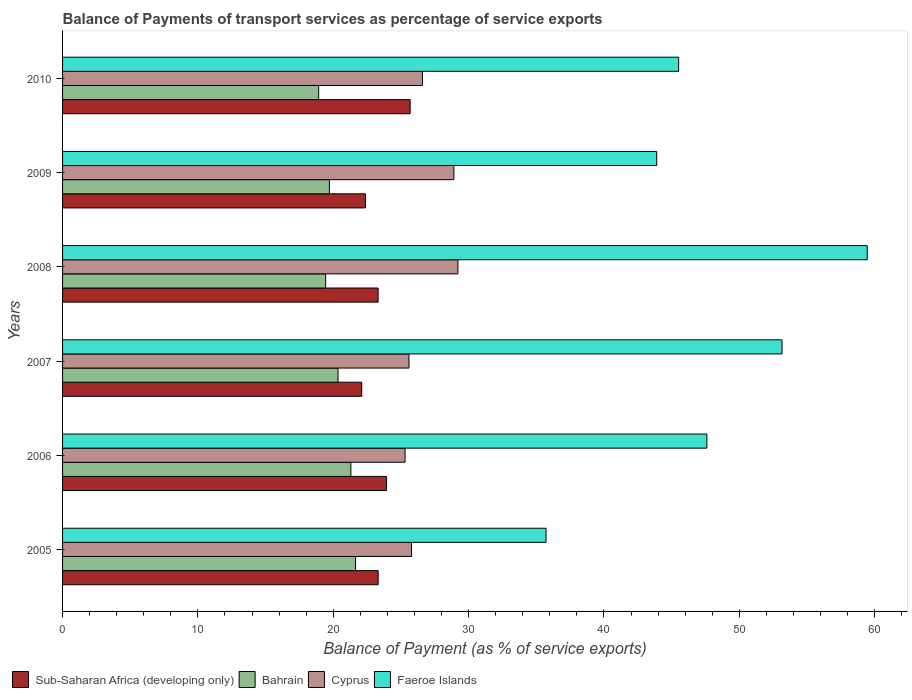How many different coloured bars are there?
Offer a very short reply. 4. Are the number of bars per tick equal to the number of legend labels?
Offer a very short reply. Yes. Are the number of bars on each tick of the Y-axis equal?
Offer a very short reply. Yes. How many bars are there on the 1st tick from the bottom?
Make the answer very short. 4. What is the label of the 1st group of bars from the top?
Keep it short and to the point. 2010. What is the balance of payments of transport services in Cyprus in 2005?
Offer a terse response. 25.78. Across all years, what is the maximum balance of payments of transport services in Bahrain?
Keep it short and to the point. 21.65. Across all years, what is the minimum balance of payments of transport services in Sub-Saharan Africa (developing only)?
Offer a very short reply. 22.1. In which year was the balance of payments of transport services in Sub-Saharan Africa (developing only) maximum?
Ensure brevity in your answer.  2010. What is the total balance of payments of transport services in Bahrain in the graph?
Your response must be concise. 121.38. What is the difference between the balance of payments of transport services in Sub-Saharan Africa (developing only) in 2007 and that in 2009?
Make the answer very short. -0.27. What is the difference between the balance of payments of transport services in Cyprus in 2009 and the balance of payments of transport services in Faeroe Islands in 2007?
Ensure brevity in your answer.  -24.25. What is the average balance of payments of transport services in Sub-Saharan Africa (developing only) per year?
Provide a short and direct response. 23.46. In the year 2009, what is the difference between the balance of payments of transport services in Cyprus and balance of payments of transport services in Bahrain?
Your answer should be very brief. 9.2. In how many years, is the balance of payments of transport services in Faeroe Islands greater than 14 %?
Offer a terse response. 6. What is the ratio of the balance of payments of transport services in Faeroe Islands in 2005 to that in 2010?
Offer a terse response. 0.78. Is the balance of payments of transport services in Bahrain in 2005 less than that in 2008?
Ensure brevity in your answer.  No. What is the difference between the highest and the second highest balance of payments of transport services in Bahrain?
Your answer should be compact. 0.35. What is the difference between the highest and the lowest balance of payments of transport services in Bahrain?
Provide a succinct answer. 2.72. In how many years, is the balance of payments of transport services in Faeroe Islands greater than the average balance of payments of transport services in Faeroe Islands taken over all years?
Offer a terse response. 3. What does the 1st bar from the top in 2008 represents?
Your answer should be very brief. Faeroe Islands. What does the 4th bar from the bottom in 2006 represents?
Make the answer very short. Faeroe Islands. How many bars are there?
Make the answer very short. 24. Are all the bars in the graph horizontal?
Make the answer very short. Yes. Are the values on the major ticks of X-axis written in scientific E-notation?
Provide a short and direct response. No. Where does the legend appear in the graph?
Make the answer very short. Bottom left. How many legend labels are there?
Provide a short and direct response. 4. How are the legend labels stacked?
Give a very brief answer. Horizontal. What is the title of the graph?
Your answer should be compact. Balance of Payments of transport services as percentage of service exports. Does "Ecuador" appear as one of the legend labels in the graph?
Offer a terse response. No. What is the label or title of the X-axis?
Offer a terse response. Balance of Payment (as % of service exports). What is the label or title of the Y-axis?
Provide a succinct answer. Years. What is the Balance of Payment (as % of service exports) of Sub-Saharan Africa (developing only) in 2005?
Your answer should be compact. 23.32. What is the Balance of Payment (as % of service exports) in Bahrain in 2005?
Make the answer very short. 21.65. What is the Balance of Payment (as % of service exports) of Cyprus in 2005?
Provide a short and direct response. 25.78. What is the Balance of Payment (as % of service exports) of Faeroe Islands in 2005?
Your answer should be compact. 35.72. What is the Balance of Payment (as % of service exports) in Sub-Saharan Africa (developing only) in 2006?
Your answer should be very brief. 23.94. What is the Balance of Payment (as % of service exports) in Bahrain in 2006?
Your answer should be very brief. 21.3. What is the Balance of Payment (as % of service exports) in Cyprus in 2006?
Your answer should be very brief. 25.31. What is the Balance of Payment (as % of service exports) in Faeroe Islands in 2006?
Ensure brevity in your answer.  47.61. What is the Balance of Payment (as % of service exports) of Sub-Saharan Africa (developing only) in 2007?
Provide a succinct answer. 22.1. What is the Balance of Payment (as % of service exports) in Bahrain in 2007?
Give a very brief answer. 20.35. What is the Balance of Payment (as % of service exports) in Cyprus in 2007?
Keep it short and to the point. 25.6. What is the Balance of Payment (as % of service exports) in Faeroe Islands in 2007?
Offer a terse response. 53.16. What is the Balance of Payment (as % of service exports) in Sub-Saharan Africa (developing only) in 2008?
Your response must be concise. 23.32. What is the Balance of Payment (as % of service exports) of Bahrain in 2008?
Offer a very short reply. 19.44. What is the Balance of Payment (as % of service exports) of Cyprus in 2008?
Your answer should be very brief. 29.21. What is the Balance of Payment (as % of service exports) of Faeroe Islands in 2008?
Ensure brevity in your answer.  59.46. What is the Balance of Payment (as % of service exports) in Sub-Saharan Africa (developing only) in 2009?
Ensure brevity in your answer.  22.38. What is the Balance of Payment (as % of service exports) in Bahrain in 2009?
Provide a succinct answer. 19.72. What is the Balance of Payment (as % of service exports) in Cyprus in 2009?
Offer a very short reply. 28.91. What is the Balance of Payment (as % of service exports) of Faeroe Islands in 2009?
Provide a succinct answer. 43.9. What is the Balance of Payment (as % of service exports) in Sub-Saharan Africa (developing only) in 2010?
Ensure brevity in your answer.  25.68. What is the Balance of Payment (as % of service exports) of Bahrain in 2010?
Your answer should be very brief. 18.92. What is the Balance of Payment (as % of service exports) of Cyprus in 2010?
Make the answer very short. 26.59. What is the Balance of Payment (as % of service exports) of Faeroe Islands in 2010?
Ensure brevity in your answer.  45.52. Across all years, what is the maximum Balance of Payment (as % of service exports) of Sub-Saharan Africa (developing only)?
Give a very brief answer. 25.68. Across all years, what is the maximum Balance of Payment (as % of service exports) of Bahrain?
Your response must be concise. 21.65. Across all years, what is the maximum Balance of Payment (as % of service exports) of Cyprus?
Your answer should be compact. 29.21. Across all years, what is the maximum Balance of Payment (as % of service exports) of Faeroe Islands?
Give a very brief answer. 59.46. Across all years, what is the minimum Balance of Payment (as % of service exports) of Sub-Saharan Africa (developing only)?
Keep it short and to the point. 22.1. Across all years, what is the minimum Balance of Payment (as % of service exports) in Bahrain?
Make the answer very short. 18.92. Across all years, what is the minimum Balance of Payment (as % of service exports) of Cyprus?
Your answer should be very brief. 25.31. Across all years, what is the minimum Balance of Payment (as % of service exports) in Faeroe Islands?
Give a very brief answer. 35.72. What is the total Balance of Payment (as % of service exports) of Sub-Saharan Africa (developing only) in the graph?
Ensure brevity in your answer.  140.73. What is the total Balance of Payment (as % of service exports) of Bahrain in the graph?
Offer a terse response. 121.38. What is the total Balance of Payment (as % of service exports) of Cyprus in the graph?
Make the answer very short. 161.4. What is the total Balance of Payment (as % of service exports) of Faeroe Islands in the graph?
Give a very brief answer. 285.37. What is the difference between the Balance of Payment (as % of service exports) of Sub-Saharan Africa (developing only) in 2005 and that in 2006?
Give a very brief answer. -0.62. What is the difference between the Balance of Payment (as % of service exports) in Bahrain in 2005 and that in 2006?
Your answer should be very brief. 0.35. What is the difference between the Balance of Payment (as % of service exports) of Cyprus in 2005 and that in 2006?
Offer a terse response. 0.48. What is the difference between the Balance of Payment (as % of service exports) in Faeroe Islands in 2005 and that in 2006?
Offer a very short reply. -11.88. What is the difference between the Balance of Payment (as % of service exports) in Sub-Saharan Africa (developing only) in 2005 and that in 2007?
Offer a terse response. 1.22. What is the difference between the Balance of Payment (as % of service exports) of Bahrain in 2005 and that in 2007?
Offer a terse response. 1.29. What is the difference between the Balance of Payment (as % of service exports) in Cyprus in 2005 and that in 2007?
Provide a succinct answer. 0.19. What is the difference between the Balance of Payment (as % of service exports) in Faeroe Islands in 2005 and that in 2007?
Offer a terse response. -17.44. What is the difference between the Balance of Payment (as % of service exports) in Sub-Saharan Africa (developing only) in 2005 and that in 2008?
Your answer should be compact. 0. What is the difference between the Balance of Payment (as % of service exports) in Bahrain in 2005 and that in 2008?
Make the answer very short. 2.21. What is the difference between the Balance of Payment (as % of service exports) of Cyprus in 2005 and that in 2008?
Keep it short and to the point. -3.43. What is the difference between the Balance of Payment (as % of service exports) of Faeroe Islands in 2005 and that in 2008?
Make the answer very short. -23.73. What is the difference between the Balance of Payment (as % of service exports) in Sub-Saharan Africa (developing only) in 2005 and that in 2009?
Keep it short and to the point. 0.94. What is the difference between the Balance of Payment (as % of service exports) of Bahrain in 2005 and that in 2009?
Your response must be concise. 1.93. What is the difference between the Balance of Payment (as % of service exports) in Cyprus in 2005 and that in 2009?
Provide a succinct answer. -3.13. What is the difference between the Balance of Payment (as % of service exports) of Faeroe Islands in 2005 and that in 2009?
Offer a very short reply. -8.18. What is the difference between the Balance of Payment (as % of service exports) in Sub-Saharan Africa (developing only) in 2005 and that in 2010?
Ensure brevity in your answer.  -2.36. What is the difference between the Balance of Payment (as % of service exports) of Bahrain in 2005 and that in 2010?
Keep it short and to the point. 2.73. What is the difference between the Balance of Payment (as % of service exports) of Cyprus in 2005 and that in 2010?
Offer a very short reply. -0.81. What is the difference between the Balance of Payment (as % of service exports) in Faeroe Islands in 2005 and that in 2010?
Make the answer very short. -9.8. What is the difference between the Balance of Payment (as % of service exports) in Sub-Saharan Africa (developing only) in 2006 and that in 2007?
Provide a succinct answer. 1.83. What is the difference between the Balance of Payment (as % of service exports) of Bahrain in 2006 and that in 2007?
Keep it short and to the point. 0.95. What is the difference between the Balance of Payment (as % of service exports) in Cyprus in 2006 and that in 2007?
Give a very brief answer. -0.29. What is the difference between the Balance of Payment (as % of service exports) of Faeroe Islands in 2006 and that in 2007?
Your answer should be compact. -5.55. What is the difference between the Balance of Payment (as % of service exports) in Sub-Saharan Africa (developing only) in 2006 and that in 2008?
Ensure brevity in your answer.  0.62. What is the difference between the Balance of Payment (as % of service exports) in Bahrain in 2006 and that in 2008?
Your answer should be compact. 1.86. What is the difference between the Balance of Payment (as % of service exports) in Cyprus in 2006 and that in 2008?
Give a very brief answer. -3.91. What is the difference between the Balance of Payment (as % of service exports) in Faeroe Islands in 2006 and that in 2008?
Provide a succinct answer. -11.85. What is the difference between the Balance of Payment (as % of service exports) of Sub-Saharan Africa (developing only) in 2006 and that in 2009?
Provide a succinct answer. 1.56. What is the difference between the Balance of Payment (as % of service exports) in Bahrain in 2006 and that in 2009?
Provide a short and direct response. 1.59. What is the difference between the Balance of Payment (as % of service exports) of Cyprus in 2006 and that in 2009?
Offer a terse response. -3.61. What is the difference between the Balance of Payment (as % of service exports) in Faeroe Islands in 2006 and that in 2009?
Offer a very short reply. 3.71. What is the difference between the Balance of Payment (as % of service exports) in Sub-Saharan Africa (developing only) in 2006 and that in 2010?
Make the answer very short. -1.75. What is the difference between the Balance of Payment (as % of service exports) in Bahrain in 2006 and that in 2010?
Offer a terse response. 2.38. What is the difference between the Balance of Payment (as % of service exports) of Cyprus in 2006 and that in 2010?
Offer a terse response. -1.28. What is the difference between the Balance of Payment (as % of service exports) in Faeroe Islands in 2006 and that in 2010?
Provide a short and direct response. 2.09. What is the difference between the Balance of Payment (as % of service exports) in Sub-Saharan Africa (developing only) in 2007 and that in 2008?
Provide a succinct answer. -1.21. What is the difference between the Balance of Payment (as % of service exports) in Bahrain in 2007 and that in 2008?
Keep it short and to the point. 0.92. What is the difference between the Balance of Payment (as % of service exports) in Cyprus in 2007 and that in 2008?
Ensure brevity in your answer.  -3.62. What is the difference between the Balance of Payment (as % of service exports) of Faeroe Islands in 2007 and that in 2008?
Your answer should be compact. -6.3. What is the difference between the Balance of Payment (as % of service exports) in Sub-Saharan Africa (developing only) in 2007 and that in 2009?
Make the answer very short. -0.27. What is the difference between the Balance of Payment (as % of service exports) in Bahrain in 2007 and that in 2009?
Offer a very short reply. 0.64. What is the difference between the Balance of Payment (as % of service exports) of Cyprus in 2007 and that in 2009?
Your response must be concise. -3.32. What is the difference between the Balance of Payment (as % of service exports) of Faeroe Islands in 2007 and that in 2009?
Your answer should be compact. 9.26. What is the difference between the Balance of Payment (as % of service exports) of Sub-Saharan Africa (developing only) in 2007 and that in 2010?
Your answer should be very brief. -3.58. What is the difference between the Balance of Payment (as % of service exports) in Bahrain in 2007 and that in 2010?
Make the answer very short. 1.43. What is the difference between the Balance of Payment (as % of service exports) of Cyprus in 2007 and that in 2010?
Make the answer very short. -0.99. What is the difference between the Balance of Payment (as % of service exports) in Faeroe Islands in 2007 and that in 2010?
Provide a succinct answer. 7.64. What is the difference between the Balance of Payment (as % of service exports) in Sub-Saharan Africa (developing only) in 2008 and that in 2009?
Your response must be concise. 0.94. What is the difference between the Balance of Payment (as % of service exports) of Bahrain in 2008 and that in 2009?
Provide a succinct answer. -0.28. What is the difference between the Balance of Payment (as % of service exports) in Cyprus in 2008 and that in 2009?
Offer a very short reply. 0.3. What is the difference between the Balance of Payment (as % of service exports) of Faeroe Islands in 2008 and that in 2009?
Your answer should be very brief. 15.56. What is the difference between the Balance of Payment (as % of service exports) in Sub-Saharan Africa (developing only) in 2008 and that in 2010?
Your response must be concise. -2.37. What is the difference between the Balance of Payment (as % of service exports) in Bahrain in 2008 and that in 2010?
Make the answer very short. 0.52. What is the difference between the Balance of Payment (as % of service exports) in Cyprus in 2008 and that in 2010?
Offer a terse response. 2.62. What is the difference between the Balance of Payment (as % of service exports) in Faeroe Islands in 2008 and that in 2010?
Offer a very short reply. 13.94. What is the difference between the Balance of Payment (as % of service exports) of Sub-Saharan Africa (developing only) in 2009 and that in 2010?
Offer a very short reply. -3.3. What is the difference between the Balance of Payment (as % of service exports) of Bahrain in 2009 and that in 2010?
Your answer should be compact. 0.79. What is the difference between the Balance of Payment (as % of service exports) in Cyprus in 2009 and that in 2010?
Offer a terse response. 2.32. What is the difference between the Balance of Payment (as % of service exports) in Faeroe Islands in 2009 and that in 2010?
Give a very brief answer. -1.62. What is the difference between the Balance of Payment (as % of service exports) of Sub-Saharan Africa (developing only) in 2005 and the Balance of Payment (as % of service exports) of Bahrain in 2006?
Make the answer very short. 2.02. What is the difference between the Balance of Payment (as % of service exports) of Sub-Saharan Africa (developing only) in 2005 and the Balance of Payment (as % of service exports) of Cyprus in 2006?
Your response must be concise. -1.99. What is the difference between the Balance of Payment (as % of service exports) in Sub-Saharan Africa (developing only) in 2005 and the Balance of Payment (as % of service exports) in Faeroe Islands in 2006?
Provide a short and direct response. -24.29. What is the difference between the Balance of Payment (as % of service exports) in Bahrain in 2005 and the Balance of Payment (as % of service exports) in Cyprus in 2006?
Ensure brevity in your answer.  -3.66. What is the difference between the Balance of Payment (as % of service exports) in Bahrain in 2005 and the Balance of Payment (as % of service exports) in Faeroe Islands in 2006?
Your response must be concise. -25.96. What is the difference between the Balance of Payment (as % of service exports) of Cyprus in 2005 and the Balance of Payment (as % of service exports) of Faeroe Islands in 2006?
Your answer should be compact. -21.82. What is the difference between the Balance of Payment (as % of service exports) of Sub-Saharan Africa (developing only) in 2005 and the Balance of Payment (as % of service exports) of Bahrain in 2007?
Keep it short and to the point. 2.96. What is the difference between the Balance of Payment (as % of service exports) in Sub-Saharan Africa (developing only) in 2005 and the Balance of Payment (as % of service exports) in Cyprus in 2007?
Make the answer very short. -2.28. What is the difference between the Balance of Payment (as % of service exports) of Sub-Saharan Africa (developing only) in 2005 and the Balance of Payment (as % of service exports) of Faeroe Islands in 2007?
Your response must be concise. -29.84. What is the difference between the Balance of Payment (as % of service exports) in Bahrain in 2005 and the Balance of Payment (as % of service exports) in Cyprus in 2007?
Offer a terse response. -3.95. What is the difference between the Balance of Payment (as % of service exports) in Bahrain in 2005 and the Balance of Payment (as % of service exports) in Faeroe Islands in 2007?
Your answer should be very brief. -31.51. What is the difference between the Balance of Payment (as % of service exports) in Cyprus in 2005 and the Balance of Payment (as % of service exports) in Faeroe Islands in 2007?
Offer a terse response. -27.38. What is the difference between the Balance of Payment (as % of service exports) in Sub-Saharan Africa (developing only) in 2005 and the Balance of Payment (as % of service exports) in Bahrain in 2008?
Provide a succinct answer. 3.88. What is the difference between the Balance of Payment (as % of service exports) of Sub-Saharan Africa (developing only) in 2005 and the Balance of Payment (as % of service exports) of Cyprus in 2008?
Provide a succinct answer. -5.89. What is the difference between the Balance of Payment (as % of service exports) in Sub-Saharan Africa (developing only) in 2005 and the Balance of Payment (as % of service exports) in Faeroe Islands in 2008?
Your answer should be very brief. -36.14. What is the difference between the Balance of Payment (as % of service exports) in Bahrain in 2005 and the Balance of Payment (as % of service exports) in Cyprus in 2008?
Your answer should be very brief. -7.56. What is the difference between the Balance of Payment (as % of service exports) of Bahrain in 2005 and the Balance of Payment (as % of service exports) of Faeroe Islands in 2008?
Give a very brief answer. -37.81. What is the difference between the Balance of Payment (as % of service exports) of Cyprus in 2005 and the Balance of Payment (as % of service exports) of Faeroe Islands in 2008?
Your answer should be very brief. -33.67. What is the difference between the Balance of Payment (as % of service exports) in Sub-Saharan Africa (developing only) in 2005 and the Balance of Payment (as % of service exports) in Bahrain in 2009?
Give a very brief answer. 3.6. What is the difference between the Balance of Payment (as % of service exports) in Sub-Saharan Africa (developing only) in 2005 and the Balance of Payment (as % of service exports) in Cyprus in 2009?
Offer a very short reply. -5.6. What is the difference between the Balance of Payment (as % of service exports) of Sub-Saharan Africa (developing only) in 2005 and the Balance of Payment (as % of service exports) of Faeroe Islands in 2009?
Ensure brevity in your answer.  -20.58. What is the difference between the Balance of Payment (as % of service exports) of Bahrain in 2005 and the Balance of Payment (as % of service exports) of Cyprus in 2009?
Your answer should be very brief. -7.27. What is the difference between the Balance of Payment (as % of service exports) in Bahrain in 2005 and the Balance of Payment (as % of service exports) in Faeroe Islands in 2009?
Keep it short and to the point. -22.25. What is the difference between the Balance of Payment (as % of service exports) in Cyprus in 2005 and the Balance of Payment (as % of service exports) in Faeroe Islands in 2009?
Offer a terse response. -18.12. What is the difference between the Balance of Payment (as % of service exports) of Sub-Saharan Africa (developing only) in 2005 and the Balance of Payment (as % of service exports) of Bahrain in 2010?
Keep it short and to the point. 4.39. What is the difference between the Balance of Payment (as % of service exports) of Sub-Saharan Africa (developing only) in 2005 and the Balance of Payment (as % of service exports) of Cyprus in 2010?
Make the answer very short. -3.27. What is the difference between the Balance of Payment (as % of service exports) in Sub-Saharan Africa (developing only) in 2005 and the Balance of Payment (as % of service exports) in Faeroe Islands in 2010?
Your answer should be compact. -22.2. What is the difference between the Balance of Payment (as % of service exports) of Bahrain in 2005 and the Balance of Payment (as % of service exports) of Cyprus in 2010?
Your response must be concise. -4.94. What is the difference between the Balance of Payment (as % of service exports) of Bahrain in 2005 and the Balance of Payment (as % of service exports) of Faeroe Islands in 2010?
Provide a short and direct response. -23.87. What is the difference between the Balance of Payment (as % of service exports) of Cyprus in 2005 and the Balance of Payment (as % of service exports) of Faeroe Islands in 2010?
Offer a very short reply. -19.74. What is the difference between the Balance of Payment (as % of service exports) in Sub-Saharan Africa (developing only) in 2006 and the Balance of Payment (as % of service exports) in Bahrain in 2007?
Your response must be concise. 3.58. What is the difference between the Balance of Payment (as % of service exports) in Sub-Saharan Africa (developing only) in 2006 and the Balance of Payment (as % of service exports) in Cyprus in 2007?
Make the answer very short. -1.66. What is the difference between the Balance of Payment (as % of service exports) of Sub-Saharan Africa (developing only) in 2006 and the Balance of Payment (as % of service exports) of Faeroe Islands in 2007?
Your answer should be very brief. -29.22. What is the difference between the Balance of Payment (as % of service exports) of Bahrain in 2006 and the Balance of Payment (as % of service exports) of Cyprus in 2007?
Provide a short and direct response. -4.29. What is the difference between the Balance of Payment (as % of service exports) in Bahrain in 2006 and the Balance of Payment (as % of service exports) in Faeroe Islands in 2007?
Keep it short and to the point. -31.86. What is the difference between the Balance of Payment (as % of service exports) of Cyprus in 2006 and the Balance of Payment (as % of service exports) of Faeroe Islands in 2007?
Ensure brevity in your answer.  -27.85. What is the difference between the Balance of Payment (as % of service exports) of Sub-Saharan Africa (developing only) in 2006 and the Balance of Payment (as % of service exports) of Bahrain in 2008?
Make the answer very short. 4.5. What is the difference between the Balance of Payment (as % of service exports) of Sub-Saharan Africa (developing only) in 2006 and the Balance of Payment (as % of service exports) of Cyprus in 2008?
Your answer should be compact. -5.28. What is the difference between the Balance of Payment (as % of service exports) of Sub-Saharan Africa (developing only) in 2006 and the Balance of Payment (as % of service exports) of Faeroe Islands in 2008?
Provide a succinct answer. -35.52. What is the difference between the Balance of Payment (as % of service exports) of Bahrain in 2006 and the Balance of Payment (as % of service exports) of Cyprus in 2008?
Give a very brief answer. -7.91. What is the difference between the Balance of Payment (as % of service exports) in Bahrain in 2006 and the Balance of Payment (as % of service exports) in Faeroe Islands in 2008?
Provide a short and direct response. -38.16. What is the difference between the Balance of Payment (as % of service exports) of Cyprus in 2006 and the Balance of Payment (as % of service exports) of Faeroe Islands in 2008?
Provide a succinct answer. -34.15. What is the difference between the Balance of Payment (as % of service exports) in Sub-Saharan Africa (developing only) in 2006 and the Balance of Payment (as % of service exports) in Bahrain in 2009?
Ensure brevity in your answer.  4.22. What is the difference between the Balance of Payment (as % of service exports) in Sub-Saharan Africa (developing only) in 2006 and the Balance of Payment (as % of service exports) in Cyprus in 2009?
Your answer should be very brief. -4.98. What is the difference between the Balance of Payment (as % of service exports) in Sub-Saharan Africa (developing only) in 2006 and the Balance of Payment (as % of service exports) in Faeroe Islands in 2009?
Ensure brevity in your answer.  -19.96. What is the difference between the Balance of Payment (as % of service exports) in Bahrain in 2006 and the Balance of Payment (as % of service exports) in Cyprus in 2009?
Your response must be concise. -7.61. What is the difference between the Balance of Payment (as % of service exports) in Bahrain in 2006 and the Balance of Payment (as % of service exports) in Faeroe Islands in 2009?
Offer a very short reply. -22.6. What is the difference between the Balance of Payment (as % of service exports) in Cyprus in 2006 and the Balance of Payment (as % of service exports) in Faeroe Islands in 2009?
Your answer should be compact. -18.59. What is the difference between the Balance of Payment (as % of service exports) in Sub-Saharan Africa (developing only) in 2006 and the Balance of Payment (as % of service exports) in Bahrain in 2010?
Provide a short and direct response. 5.01. What is the difference between the Balance of Payment (as % of service exports) in Sub-Saharan Africa (developing only) in 2006 and the Balance of Payment (as % of service exports) in Cyprus in 2010?
Your answer should be very brief. -2.65. What is the difference between the Balance of Payment (as % of service exports) of Sub-Saharan Africa (developing only) in 2006 and the Balance of Payment (as % of service exports) of Faeroe Islands in 2010?
Make the answer very short. -21.58. What is the difference between the Balance of Payment (as % of service exports) of Bahrain in 2006 and the Balance of Payment (as % of service exports) of Cyprus in 2010?
Your answer should be very brief. -5.29. What is the difference between the Balance of Payment (as % of service exports) in Bahrain in 2006 and the Balance of Payment (as % of service exports) in Faeroe Islands in 2010?
Offer a terse response. -24.22. What is the difference between the Balance of Payment (as % of service exports) in Cyprus in 2006 and the Balance of Payment (as % of service exports) in Faeroe Islands in 2010?
Offer a very short reply. -20.21. What is the difference between the Balance of Payment (as % of service exports) of Sub-Saharan Africa (developing only) in 2007 and the Balance of Payment (as % of service exports) of Bahrain in 2008?
Ensure brevity in your answer.  2.66. What is the difference between the Balance of Payment (as % of service exports) in Sub-Saharan Africa (developing only) in 2007 and the Balance of Payment (as % of service exports) in Cyprus in 2008?
Provide a succinct answer. -7.11. What is the difference between the Balance of Payment (as % of service exports) in Sub-Saharan Africa (developing only) in 2007 and the Balance of Payment (as % of service exports) in Faeroe Islands in 2008?
Offer a very short reply. -37.35. What is the difference between the Balance of Payment (as % of service exports) in Bahrain in 2007 and the Balance of Payment (as % of service exports) in Cyprus in 2008?
Provide a short and direct response. -8.86. What is the difference between the Balance of Payment (as % of service exports) of Bahrain in 2007 and the Balance of Payment (as % of service exports) of Faeroe Islands in 2008?
Provide a short and direct response. -39.1. What is the difference between the Balance of Payment (as % of service exports) in Cyprus in 2007 and the Balance of Payment (as % of service exports) in Faeroe Islands in 2008?
Provide a short and direct response. -33.86. What is the difference between the Balance of Payment (as % of service exports) in Sub-Saharan Africa (developing only) in 2007 and the Balance of Payment (as % of service exports) in Bahrain in 2009?
Offer a terse response. 2.39. What is the difference between the Balance of Payment (as % of service exports) of Sub-Saharan Africa (developing only) in 2007 and the Balance of Payment (as % of service exports) of Cyprus in 2009?
Ensure brevity in your answer.  -6.81. What is the difference between the Balance of Payment (as % of service exports) of Sub-Saharan Africa (developing only) in 2007 and the Balance of Payment (as % of service exports) of Faeroe Islands in 2009?
Make the answer very short. -21.8. What is the difference between the Balance of Payment (as % of service exports) of Bahrain in 2007 and the Balance of Payment (as % of service exports) of Cyprus in 2009?
Your response must be concise. -8.56. What is the difference between the Balance of Payment (as % of service exports) in Bahrain in 2007 and the Balance of Payment (as % of service exports) in Faeroe Islands in 2009?
Your answer should be compact. -23.55. What is the difference between the Balance of Payment (as % of service exports) of Cyprus in 2007 and the Balance of Payment (as % of service exports) of Faeroe Islands in 2009?
Your answer should be compact. -18.3. What is the difference between the Balance of Payment (as % of service exports) in Sub-Saharan Africa (developing only) in 2007 and the Balance of Payment (as % of service exports) in Bahrain in 2010?
Provide a short and direct response. 3.18. What is the difference between the Balance of Payment (as % of service exports) in Sub-Saharan Africa (developing only) in 2007 and the Balance of Payment (as % of service exports) in Cyprus in 2010?
Offer a terse response. -4.49. What is the difference between the Balance of Payment (as % of service exports) of Sub-Saharan Africa (developing only) in 2007 and the Balance of Payment (as % of service exports) of Faeroe Islands in 2010?
Your answer should be very brief. -23.42. What is the difference between the Balance of Payment (as % of service exports) of Bahrain in 2007 and the Balance of Payment (as % of service exports) of Cyprus in 2010?
Make the answer very short. -6.24. What is the difference between the Balance of Payment (as % of service exports) in Bahrain in 2007 and the Balance of Payment (as % of service exports) in Faeroe Islands in 2010?
Keep it short and to the point. -25.16. What is the difference between the Balance of Payment (as % of service exports) of Cyprus in 2007 and the Balance of Payment (as % of service exports) of Faeroe Islands in 2010?
Provide a succinct answer. -19.92. What is the difference between the Balance of Payment (as % of service exports) in Sub-Saharan Africa (developing only) in 2008 and the Balance of Payment (as % of service exports) in Bahrain in 2009?
Your response must be concise. 3.6. What is the difference between the Balance of Payment (as % of service exports) of Sub-Saharan Africa (developing only) in 2008 and the Balance of Payment (as % of service exports) of Cyprus in 2009?
Ensure brevity in your answer.  -5.6. What is the difference between the Balance of Payment (as % of service exports) in Sub-Saharan Africa (developing only) in 2008 and the Balance of Payment (as % of service exports) in Faeroe Islands in 2009?
Offer a terse response. -20.58. What is the difference between the Balance of Payment (as % of service exports) of Bahrain in 2008 and the Balance of Payment (as % of service exports) of Cyprus in 2009?
Offer a very short reply. -9.47. What is the difference between the Balance of Payment (as % of service exports) in Bahrain in 2008 and the Balance of Payment (as % of service exports) in Faeroe Islands in 2009?
Offer a very short reply. -24.46. What is the difference between the Balance of Payment (as % of service exports) of Cyprus in 2008 and the Balance of Payment (as % of service exports) of Faeroe Islands in 2009?
Your response must be concise. -14.69. What is the difference between the Balance of Payment (as % of service exports) in Sub-Saharan Africa (developing only) in 2008 and the Balance of Payment (as % of service exports) in Bahrain in 2010?
Provide a short and direct response. 4.39. What is the difference between the Balance of Payment (as % of service exports) in Sub-Saharan Africa (developing only) in 2008 and the Balance of Payment (as % of service exports) in Cyprus in 2010?
Your response must be concise. -3.27. What is the difference between the Balance of Payment (as % of service exports) of Sub-Saharan Africa (developing only) in 2008 and the Balance of Payment (as % of service exports) of Faeroe Islands in 2010?
Keep it short and to the point. -22.2. What is the difference between the Balance of Payment (as % of service exports) in Bahrain in 2008 and the Balance of Payment (as % of service exports) in Cyprus in 2010?
Provide a succinct answer. -7.15. What is the difference between the Balance of Payment (as % of service exports) of Bahrain in 2008 and the Balance of Payment (as % of service exports) of Faeroe Islands in 2010?
Provide a succinct answer. -26.08. What is the difference between the Balance of Payment (as % of service exports) of Cyprus in 2008 and the Balance of Payment (as % of service exports) of Faeroe Islands in 2010?
Your response must be concise. -16.31. What is the difference between the Balance of Payment (as % of service exports) in Sub-Saharan Africa (developing only) in 2009 and the Balance of Payment (as % of service exports) in Bahrain in 2010?
Keep it short and to the point. 3.45. What is the difference between the Balance of Payment (as % of service exports) of Sub-Saharan Africa (developing only) in 2009 and the Balance of Payment (as % of service exports) of Cyprus in 2010?
Your response must be concise. -4.21. What is the difference between the Balance of Payment (as % of service exports) in Sub-Saharan Africa (developing only) in 2009 and the Balance of Payment (as % of service exports) in Faeroe Islands in 2010?
Ensure brevity in your answer.  -23.14. What is the difference between the Balance of Payment (as % of service exports) of Bahrain in 2009 and the Balance of Payment (as % of service exports) of Cyprus in 2010?
Provide a succinct answer. -6.87. What is the difference between the Balance of Payment (as % of service exports) in Bahrain in 2009 and the Balance of Payment (as % of service exports) in Faeroe Islands in 2010?
Offer a terse response. -25.8. What is the difference between the Balance of Payment (as % of service exports) in Cyprus in 2009 and the Balance of Payment (as % of service exports) in Faeroe Islands in 2010?
Offer a very short reply. -16.61. What is the average Balance of Payment (as % of service exports) in Sub-Saharan Africa (developing only) per year?
Provide a short and direct response. 23.46. What is the average Balance of Payment (as % of service exports) of Bahrain per year?
Offer a terse response. 20.23. What is the average Balance of Payment (as % of service exports) of Cyprus per year?
Provide a succinct answer. 26.9. What is the average Balance of Payment (as % of service exports) of Faeroe Islands per year?
Make the answer very short. 47.56. In the year 2005, what is the difference between the Balance of Payment (as % of service exports) of Sub-Saharan Africa (developing only) and Balance of Payment (as % of service exports) of Bahrain?
Provide a short and direct response. 1.67. In the year 2005, what is the difference between the Balance of Payment (as % of service exports) of Sub-Saharan Africa (developing only) and Balance of Payment (as % of service exports) of Cyprus?
Offer a terse response. -2.46. In the year 2005, what is the difference between the Balance of Payment (as % of service exports) in Sub-Saharan Africa (developing only) and Balance of Payment (as % of service exports) in Faeroe Islands?
Your answer should be compact. -12.41. In the year 2005, what is the difference between the Balance of Payment (as % of service exports) in Bahrain and Balance of Payment (as % of service exports) in Cyprus?
Your answer should be very brief. -4.13. In the year 2005, what is the difference between the Balance of Payment (as % of service exports) of Bahrain and Balance of Payment (as % of service exports) of Faeroe Islands?
Give a very brief answer. -14.08. In the year 2005, what is the difference between the Balance of Payment (as % of service exports) of Cyprus and Balance of Payment (as % of service exports) of Faeroe Islands?
Provide a short and direct response. -9.94. In the year 2006, what is the difference between the Balance of Payment (as % of service exports) in Sub-Saharan Africa (developing only) and Balance of Payment (as % of service exports) in Bahrain?
Offer a very short reply. 2.64. In the year 2006, what is the difference between the Balance of Payment (as % of service exports) in Sub-Saharan Africa (developing only) and Balance of Payment (as % of service exports) in Cyprus?
Offer a very short reply. -1.37. In the year 2006, what is the difference between the Balance of Payment (as % of service exports) in Sub-Saharan Africa (developing only) and Balance of Payment (as % of service exports) in Faeroe Islands?
Keep it short and to the point. -23.67. In the year 2006, what is the difference between the Balance of Payment (as % of service exports) of Bahrain and Balance of Payment (as % of service exports) of Cyprus?
Your answer should be very brief. -4.01. In the year 2006, what is the difference between the Balance of Payment (as % of service exports) of Bahrain and Balance of Payment (as % of service exports) of Faeroe Islands?
Make the answer very short. -26.31. In the year 2006, what is the difference between the Balance of Payment (as % of service exports) in Cyprus and Balance of Payment (as % of service exports) in Faeroe Islands?
Provide a succinct answer. -22.3. In the year 2007, what is the difference between the Balance of Payment (as % of service exports) of Sub-Saharan Africa (developing only) and Balance of Payment (as % of service exports) of Bahrain?
Offer a terse response. 1.75. In the year 2007, what is the difference between the Balance of Payment (as % of service exports) of Sub-Saharan Africa (developing only) and Balance of Payment (as % of service exports) of Cyprus?
Make the answer very short. -3.49. In the year 2007, what is the difference between the Balance of Payment (as % of service exports) in Sub-Saharan Africa (developing only) and Balance of Payment (as % of service exports) in Faeroe Islands?
Provide a succinct answer. -31.06. In the year 2007, what is the difference between the Balance of Payment (as % of service exports) in Bahrain and Balance of Payment (as % of service exports) in Cyprus?
Offer a terse response. -5.24. In the year 2007, what is the difference between the Balance of Payment (as % of service exports) of Bahrain and Balance of Payment (as % of service exports) of Faeroe Islands?
Offer a terse response. -32.81. In the year 2007, what is the difference between the Balance of Payment (as % of service exports) of Cyprus and Balance of Payment (as % of service exports) of Faeroe Islands?
Keep it short and to the point. -27.56. In the year 2008, what is the difference between the Balance of Payment (as % of service exports) of Sub-Saharan Africa (developing only) and Balance of Payment (as % of service exports) of Bahrain?
Keep it short and to the point. 3.88. In the year 2008, what is the difference between the Balance of Payment (as % of service exports) in Sub-Saharan Africa (developing only) and Balance of Payment (as % of service exports) in Cyprus?
Provide a succinct answer. -5.9. In the year 2008, what is the difference between the Balance of Payment (as % of service exports) of Sub-Saharan Africa (developing only) and Balance of Payment (as % of service exports) of Faeroe Islands?
Offer a very short reply. -36.14. In the year 2008, what is the difference between the Balance of Payment (as % of service exports) in Bahrain and Balance of Payment (as % of service exports) in Cyprus?
Make the answer very short. -9.77. In the year 2008, what is the difference between the Balance of Payment (as % of service exports) in Bahrain and Balance of Payment (as % of service exports) in Faeroe Islands?
Your answer should be very brief. -40.02. In the year 2008, what is the difference between the Balance of Payment (as % of service exports) of Cyprus and Balance of Payment (as % of service exports) of Faeroe Islands?
Provide a succinct answer. -30.24. In the year 2009, what is the difference between the Balance of Payment (as % of service exports) in Sub-Saharan Africa (developing only) and Balance of Payment (as % of service exports) in Bahrain?
Give a very brief answer. 2.66. In the year 2009, what is the difference between the Balance of Payment (as % of service exports) of Sub-Saharan Africa (developing only) and Balance of Payment (as % of service exports) of Cyprus?
Your response must be concise. -6.54. In the year 2009, what is the difference between the Balance of Payment (as % of service exports) of Sub-Saharan Africa (developing only) and Balance of Payment (as % of service exports) of Faeroe Islands?
Offer a very short reply. -21.52. In the year 2009, what is the difference between the Balance of Payment (as % of service exports) of Bahrain and Balance of Payment (as % of service exports) of Cyprus?
Your response must be concise. -9.2. In the year 2009, what is the difference between the Balance of Payment (as % of service exports) in Bahrain and Balance of Payment (as % of service exports) in Faeroe Islands?
Give a very brief answer. -24.18. In the year 2009, what is the difference between the Balance of Payment (as % of service exports) of Cyprus and Balance of Payment (as % of service exports) of Faeroe Islands?
Keep it short and to the point. -14.99. In the year 2010, what is the difference between the Balance of Payment (as % of service exports) of Sub-Saharan Africa (developing only) and Balance of Payment (as % of service exports) of Bahrain?
Give a very brief answer. 6.76. In the year 2010, what is the difference between the Balance of Payment (as % of service exports) of Sub-Saharan Africa (developing only) and Balance of Payment (as % of service exports) of Cyprus?
Your answer should be compact. -0.91. In the year 2010, what is the difference between the Balance of Payment (as % of service exports) in Sub-Saharan Africa (developing only) and Balance of Payment (as % of service exports) in Faeroe Islands?
Offer a very short reply. -19.84. In the year 2010, what is the difference between the Balance of Payment (as % of service exports) of Bahrain and Balance of Payment (as % of service exports) of Cyprus?
Keep it short and to the point. -7.67. In the year 2010, what is the difference between the Balance of Payment (as % of service exports) of Bahrain and Balance of Payment (as % of service exports) of Faeroe Islands?
Provide a succinct answer. -26.6. In the year 2010, what is the difference between the Balance of Payment (as % of service exports) of Cyprus and Balance of Payment (as % of service exports) of Faeroe Islands?
Give a very brief answer. -18.93. What is the ratio of the Balance of Payment (as % of service exports) in Sub-Saharan Africa (developing only) in 2005 to that in 2006?
Ensure brevity in your answer.  0.97. What is the ratio of the Balance of Payment (as % of service exports) of Bahrain in 2005 to that in 2006?
Your answer should be very brief. 1.02. What is the ratio of the Balance of Payment (as % of service exports) in Cyprus in 2005 to that in 2006?
Offer a very short reply. 1.02. What is the ratio of the Balance of Payment (as % of service exports) of Faeroe Islands in 2005 to that in 2006?
Offer a very short reply. 0.75. What is the ratio of the Balance of Payment (as % of service exports) in Sub-Saharan Africa (developing only) in 2005 to that in 2007?
Provide a succinct answer. 1.05. What is the ratio of the Balance of Payment (as % of service exports) in Bahrain in 2005 to that in 2007?
Give a very brief answer. 1.06. What is the ratio of the Balance of Payment (as % of service exports) in Cyprus in 2005 to that in 2007?
Your answer should be very brief. 1.01. What is the ratio of the Balance of Payment (as % of service exports) of Faeroe Islands in 2005 to that in 2007?
Provide a short and direct response. 0.67. What is the ratio of the Balance of Payment (as % of service exports) of Sub-Saharan Africa (developing only) in 2005 to that in 2008?
Offer a terse response. 1. What is the ratio of the Balance of Payment (as % of service exports) in Bahrain in 2005 to that in 2008?
Keep it short and to the point. 1.11. What is the ratio of the Balance of Payment (as % of service exports) in Cyprus in 2005 to that in 2008?
Your response must be concise. 0.88. What is the ratio of the Balance of Payment (as % of service exports) in Faeroe Islands in 2005 to that in 2008?
Provide a succinct answer. 0.6. What is the ratio of the Balance of Payment (as % of service exports) of Sub-Saharan Africa (developing only) in 2005 to that in 2009?
Your answer should be compact. 1.04. What is the ratio of the Balance of Payment (as % of service exports) of Bahrain in 2005 to that in 2009?
Ensure brevity in your answer.  1.1. What is the ratio of the Balance of Payment (as % of service exports) of Cyprus in 2005 to that in 2009?
Provide a succinct answer. 0.89. What is the ratio of the Balance of Payment (as % of service exports) in Faeroe Islands in 2005 to that in 2009?
Offer a terse response. 0.81. What is the ratio of the Balance of Payment (as % of service exports) of Sub-Saharan Africa (developing only) in 2005 to that in 2010?
Provide a succinct answer. 0.91. What is the ratio of the Balance of Payment (as % of service exports) in Bahrain in 2005 to that in 2010?
Provide a short and direct response. 1.14. What is the ratio of the Balance of Payment (as % of service exports) in Cyprus in 2005 to that in 2010?
Provide a short and direct response. 0.97. What is the ratio of the Balance of Payment (as % of service exports) in Faeroe Islands in 2005 to that in 2010?
Your answer should be very brief. 0.78. What is the ratio of the Balance of Payment (as % of service exports) in Sub-Saharan Africa (developing only) in 2006 to that in 2007?
Offer a very short reply. 1.08. What is the ratio of the Balance of Payment (as % of service exports) of Bahrain in 2006 to that in 2007?
Your answer should be very brief. 1.05. What is the ratio of the Balance of Payment (as % of service exports) of Cyprus in 2006 to that in 2007?
Offer a terse response. 0.99. What is the ratio of the Balance of Payment (as % of service exports) of Faeroe Islands in 2006 to that in 2007?
Give a very brief answer. 0.9. What is the ratio of the Balance of Payment (as % of service exports) in Sub-Saharan Africa (developing only) in 2006 to that in 2008?
Give a very brief answer. 1.03. What is the ratio of the Balance of Payment (as % of service exports) of Bahrain in 2006 to that in 2008?
Your response must be concise. 1.1. What is the ratio of the Balance of Payment (as % of service exports) of Cyprus in 2006 to that in 2008?
Give a very brief answer. 0.87. What is the ratio of the Balance of Payment (as % of service exports) of Faeroe Islands in 2006 to that in 2008?
Keep it short and to the point. 0.8. What is the ratio of the Balance of Payment (as % of service exports) in Sub-Saharan Africa (developing only) in 2006 to that in 2009?
Keep it short and to the point. 1.07. What is the ratio of the Balance of Payment (as % of service exports) in Bahrain in 2006 to that in 2009?
Make the answer very short. 1.08. What is the ratio of the Balance of Payment (as % of service exports) in Cyprus in 2006 to that in 2009?
Offer a terse response. 0.88. What is the ratio of the Balance of Payment (as % of service exports) of Faeroe Islands in 2006 to that in 2009?
Keep it short and to the point. 1.08. What is the ratio of the Balance of Payment (as % of service exports) in Sub-Saharan Africa (developing only) in 2006 to that in 2010?
Provide a succinct answer. 0.93. What is the ratio of the Balance of Payment (as % of service exports) of Bahrain in 2006 to that in 2010?
Offer a very short reply. 1.13. What is the ratio of the Balance of Payment (as % of service exports) in Cyprus in 2006 to that in 2010?
Provide a succinct answer. 0.95. What is the ratio of the Balance of Payment (as % of service exports) in Faeroe Islands in 2006 to that in 2010?
Provide a short and direct response. 1.05. What is the ratio of the Balance of Payment (as % of service exports) in Sub-Saharan Africa (developing only) in 2007 to that in 2008?
Your answer should be compact. 0.95. What is the ratio of the Balance of Payment (as % of service exports) of Bahrain in 2007 to that in 2008?
Give a very brief answer. 1.05. What is the ratio of the Balance of Payment (as % of service exports) of Cyprus in 2007 to that in 2008?
Offer a terse response. 0.88. What is the ratio of the Balance of Payment (as % of service exports) of Faeroe Islands in 2007 to that in 2008?
Your answer should be compact. 0.89. What is the ratio of the Balance of Payment (as % of service exports) of Bahrain in 2007 to that in 2009?
Ensure brevity in your answer.  1.03. What is the ratio of the Balance of Payment (as % of service exports) in Cyprus in 2007 to that in 2009?
Provide a succinct answer. 0.89. What is the ratio of the Balance of Payment (as % of service exports) in Faeroe Islands in 2007 to that in 2009?
Offer a terse response. 1.21. What is the ratio of the Balance of Payment (as % of service exports) in Sub-Saharan Africa (developing only) in 2007 to that in 2010?
Give a very brief answer. 0.86. What is the ratio of the Balance of Payment (as % of service exports) in Bahrain in 2007 to that in 2010?
Provide a short and direct response. 1.08. What is the ratio of the Balance of Payment (as % of service exports) in Cyprus in 2007 to that in 2010?
Make the answer very short. 0.96. What is the ratio of the Balance of Payment (as % of service exports) in Faeroe Islands in 2007 to that in 2010?
Make the answer very short. 1.17. What is the ratio of the Balance of Payment (as % of service exports) in Sub-Saharan Africa (developing only) in 2008 to that in 2009?
Give a very brief answer. 1.04. What is the ratio of the Balance of Payment (as % of service exports) in Bahrain in 2008 to that in 2009?
Your response must be concise. 0.99. What is the ratio of the Balance of Payment (as % of service exports) of Cyprus in 2008 to that in 2009?
Give a very brief answer. 1.01. What is the ratio of the Balance of Payment (as % of service exports) in Faeroe Islands in 2008 to that in 2009?
Ensure brevity in your answer.  1.35. What is the ratio of the Balance of Payment (as % of service exports) of Sub-Saharan Africa (developing only) in 2008 to that in 2010?
Your answer should be very brief. 0.91. What is the ratio of the Balance of Payment (as % of service exports) of Bahrain in 2008 to that in 2010?
Offer a terse response. 1.03. What is the ratio of the Balance of Payment (as % of service exports) of Cyprus in 2008 to that in 2010?
Ensure brevity in your answer.  1.1. What is the ratio of the Balance of Payment (as % of service exports) in Faeroe Islands in 2008 to that in 2010?
Your answer should be compact. 1.31. What is the ratio of the Balance of Payment (as % of service exports) of Sub-Saharan Africa (developing only) in 2009 to that in 2010?
Make the answer very short. 0.87. What is the ratio of the Balance of Payment (as % of service exports) of Bahrain in 2009 to that in 2010?
Provide a succinct answer. 1.04. What is the ratio of the Balance of Payment (as % of service exports) in Cyprus in 2009 to that in 2010?
Offer a very short reply. 1.09. What is the ratio of the Balance of Payment (as % of service exports) of Faeroe Islands in 2009 to that in 2010?
Give a very brief answer. 0.96. What is the difference between the highest and the second highest Balance of Payment (as % of service exports) in Sub-Saharan Africa (developing only)?
Ensure brevity in your answer.  1.75. What is the difference between the highest and the second highest Balance of Payment (as % of service exports) in Bahrain?
Give a very brief answer. 0.35. What is the difference between the highest and the second highest Balance of Payment (as % of service exports) of Cyprus?
Keep it short and to the point. 0.3. What is the difference between the highest and the second highest Balance of Payment (as % of service exports) in Faeroe Islands?
Provide a short and direct response. 6.3. What is the difference between the highest and the lowest Balance of Payment (as % of service exports) in Sub-Saharan Africa (developing only)?
Keep it short and to the point. 3.58. What is the difference between the highest and the lowest Balance of Payment (as % of service exports) of Bahrain?
Give a very brief answer. 2.73. What is the difference between the highest and the lowest Balance of Payment (as % of service exports) in Cyprus?
Offer a terse response. 3.91. What is the difference between the highest and the lowest Balance of Payment (as % of service exports) of Faeroe Islands?
Your answer should be compact. 23.73. 